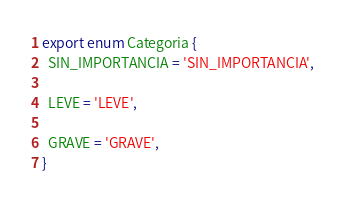<code> <loc_0><loc_0><loc_500><loc_500><_TypeScript_>export enum Categoria {
  SIN_IMPORTANCIA = 'SIN_IMPORTANCIA',

  LEVE = 'LEVE',

  GRAVE = 'GRAVE',
}
</code> 